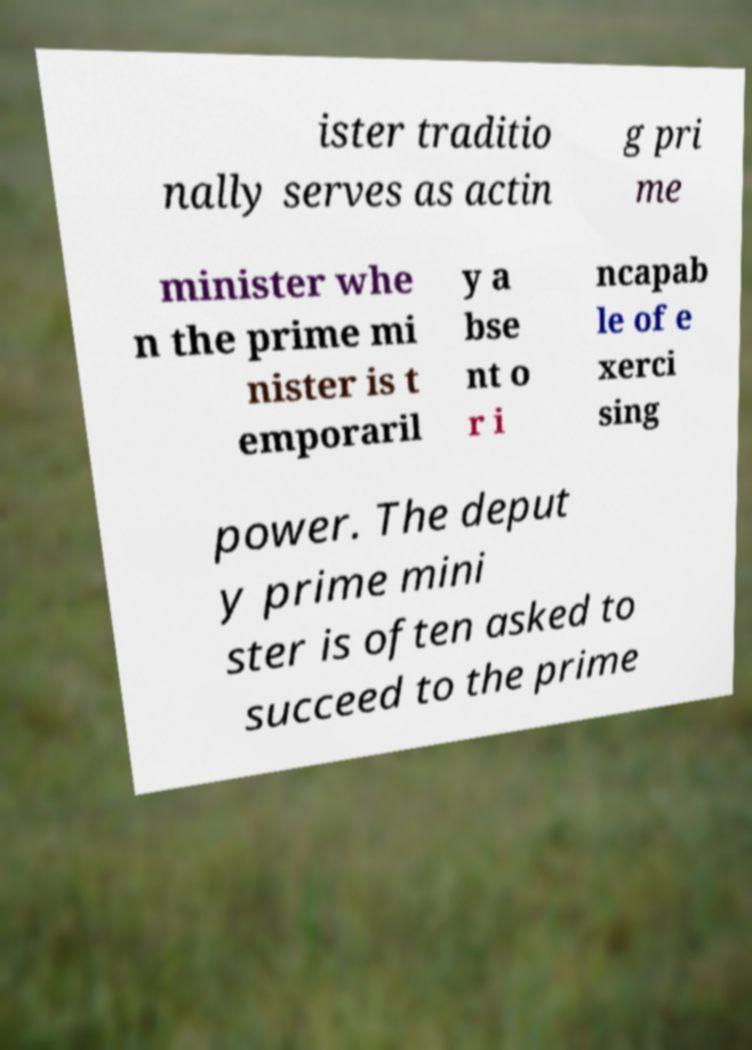Could you assist in decoding the text presented in this image and type it out clearly? ister traditio nally serves as actin g pri me minister whe n the prime mi nister is t emporaril y a bse nt o r i ncapab le of e xerci sing power. The deput y prime mini ster is often asked to succeed to the prime 